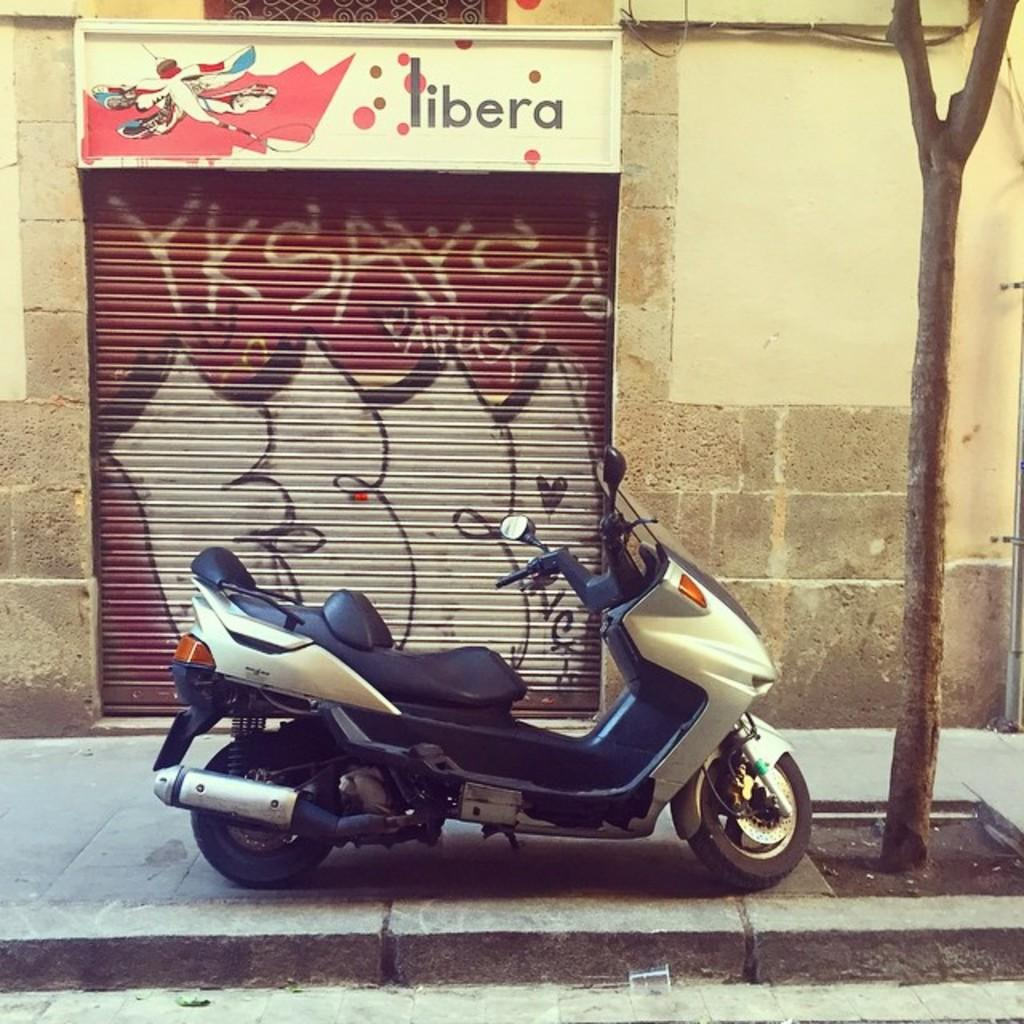What is the main object in the image? There is a bike in the image. What can be seen in the background of the image? There is a shop in the background of the image. What is located on the right side of the image? There is a tree and a wall on the right side of the image. How many bottles are placed on the bike in the image? There are no bottles present on the bike in the image. What type of ticket can be seen hanging from the tree in the image? There is no ticket hanging from the tree in the image. 